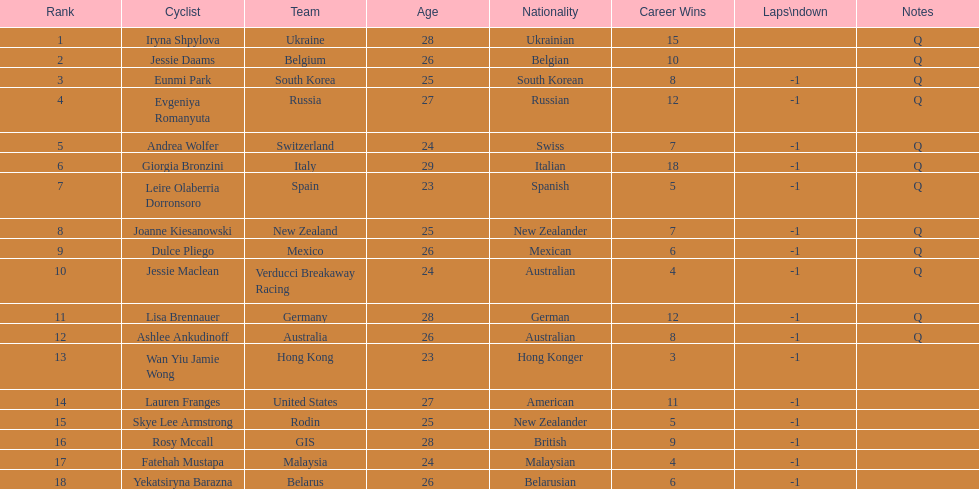In terms of ranking, where does belgium stand? 2. 